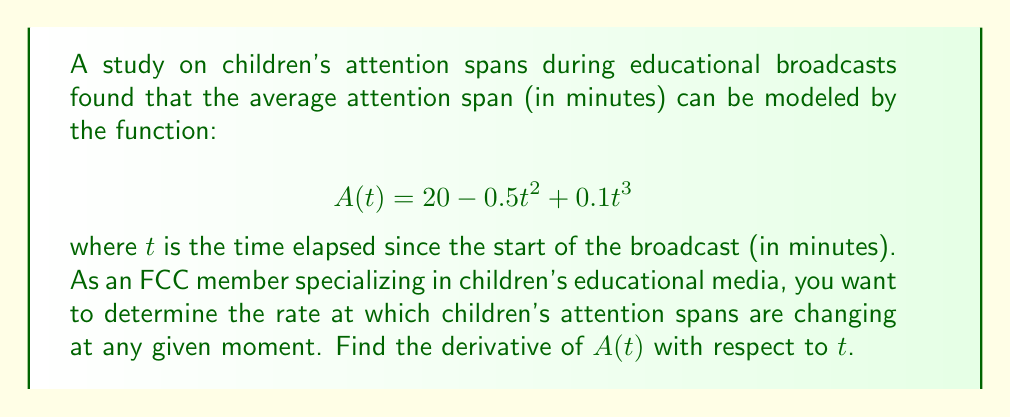Help me with this question. To find the derivative of $A(t)$ with respect to $t$, we need to apply the rules of differentiation to each term in the function:

1) The constant term: $20$
   The derivative of a constant is 0.

2) The quadratic term: $-0.5t^2$
   Use the power rule: $\frac{d}{dt}(at^n) = an \cdot t^{n-1}$
   $\frac{d}{dt}(-0.5t^2) = -0.5 \cdot 2 \cdot t^{2-1} = -t$

3) The cubic term: $0.1t^3$
   Again, use the power rule:
   $\frac{d}{dt}(0.1t^3) = 0.1 \cdot 3 \cdot t^{3-1} = 0.3t^2$

Now, we combine these results:

$$\frac{d}{dt}A(t) = 0 + (-t) + 0.3t^2 = -t + 0.3t^2$$

This derivative represents the instantaneous rate of change of children's attention spans at any given time $t$ during the educational broadcast.
Answer: $$A'(t) = -t + 0.3t^2$$ 